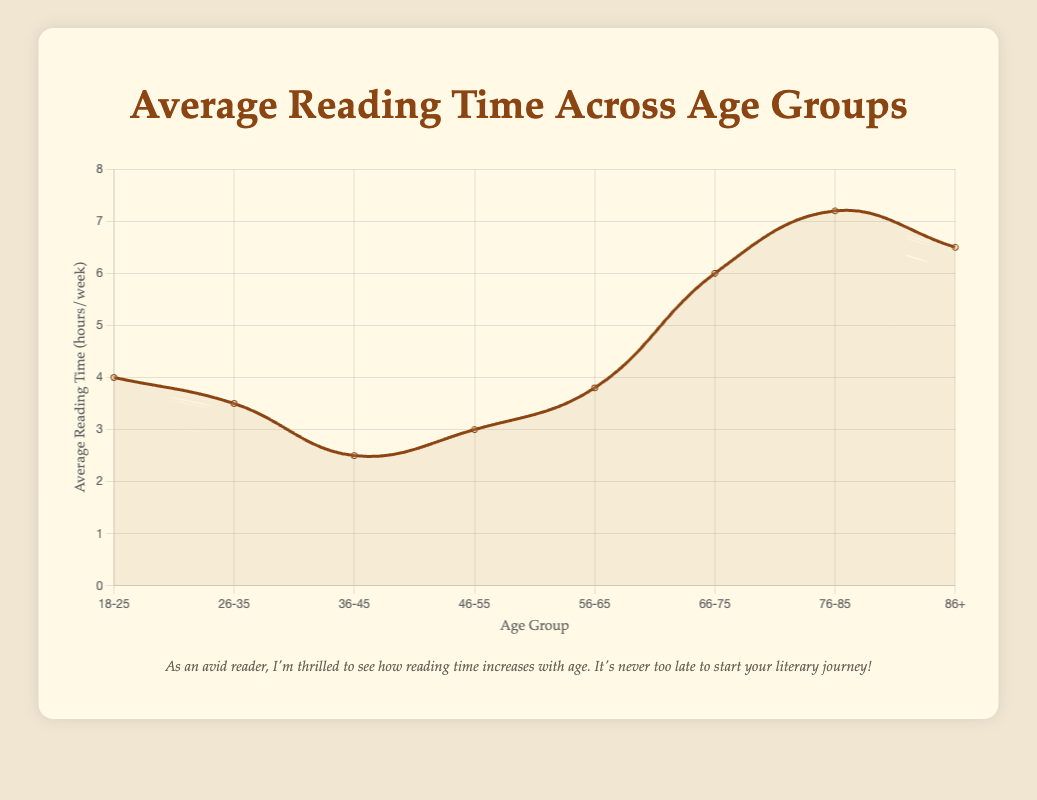What is the title of the chart? The title of the chart is displayed at the top. It reads "Average Reading Time Across Age Groups".
Answer: Average Reading Time Across Age Groups What is the total average reading time for the 56-65 age group? Refer to the data point for the 56-65 age group. It shows the average reading time is 3.8 hours per week.
Answer: 3.8 hours per week Which age group has the highest average reading time per week? The height of the area in the chart represents the average reading time for each age group. The highest point on the chart corresponds to the 76-85 age group, with an average of 7.2 hours per week.
Answer: 76-85 age group How does the average reading time for the 36-45 age group compare to the 66-75 age group? Look at the chart, find the values for the 36-45 age group (2.5 hours per week) and the 66-75 age group (6 hours per week). Compare the two values. 6 hours are greater than 2.5 hours.
Answer: The 66-75 age group reads more than the 36-45 age group What is the difference in average reading time between the youngest (18-25) and the oldest (86+) age groups? The youngest age group (18-25) reads an average of 4 hours per week, whereas the oldest age group (86+) reads 6.5 hours per week. Calculating the difference: 6.5 - 4 = 2.5 hours.
Answer: 2.5 hours What trend can you infer from the average reading time across age groups? Analyze the overall pattern in the chart. The average reading time generally decreases from the 18-25 age group to the 36-45 age group, then increases again, peaking at the 76-85 age group, and slightly decreases for the 86+ group.
Answer: Reading time generally increases with age, peaking at 76-85 What is the sum of the average reading times for the 26-35 and 46-55 age groups? The 26-35 and 46-55 age groups have average reading times of 3.5 hours and 3 hours per week respectively. Summing them up: 3.5 + 3 = 6.5 hours.
Answer: 6.5 hours How much more do people aged 76-85 read compared to those aged 26-35 per week? The 76-85 age group reads 7.2 hours per week, and the 26-35 age group reads 3.5 hours per week. The difference is 7.2 - 3.5 = 3.7 hours.
Answer: 3.7 hours What is the average reading time for the age groups 18-25, 26-35, and 36-45 combined? Add the average reading times for these age groups and divide by the number of groups: (4 + 3.5 + 2.5) / 3 = 10 / 3 = approximately 3.33 hours per week.
Answer: 3.33 hours per week How does the average reading time trend differ between the middle age groups (36-55) and the older age groups (66+)? For 36-55, the reading time is relatively low and stable (between 2.5 to 3 hours). For 66+, the reading time increases significantly (6 to 7.2 hours) and then slightly decreases for the 86+ group (6.5 hours).
Answer: Middle age groups have lower and stable reading times, while older groups have higher and increasing reading times 